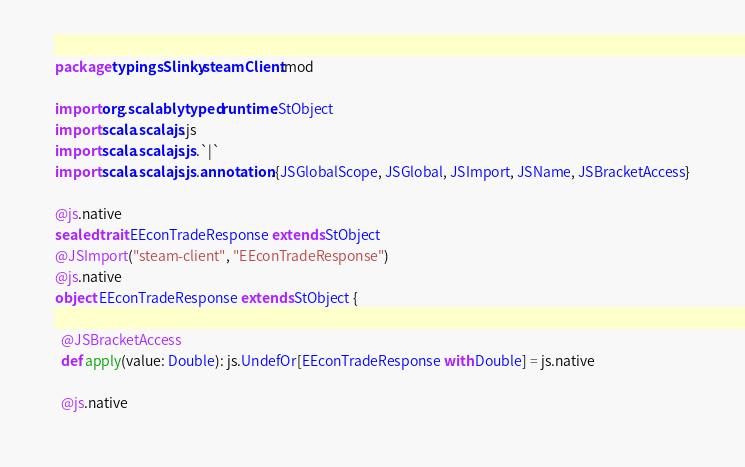Convert code to text. <code><loc_0><loc_0><loc_500><loc_500><_Scala_>package typingsSlinky.steamClient.mod

import org.scalablytyped.runtime.StObject
import scala.scalajs.js
import scala.scalajs.js.`|`
import scala.scalajs.js.annotation.{JSGlobalScope, JSGlobal, JSImport, JSName, JSBracketAccess}

@js.native
sealed trait EEconTradeResponse extends StObject
@JSImport("steam-client", "EEconTradeResponse")
@js.native
object EEconTradeResponse extends StObject {
  
  @JSBracketAccess
  def apply(value: Double): js.UndefOr[EEconTradeResponse with Double] = js.native
  
  @js.native</code> 